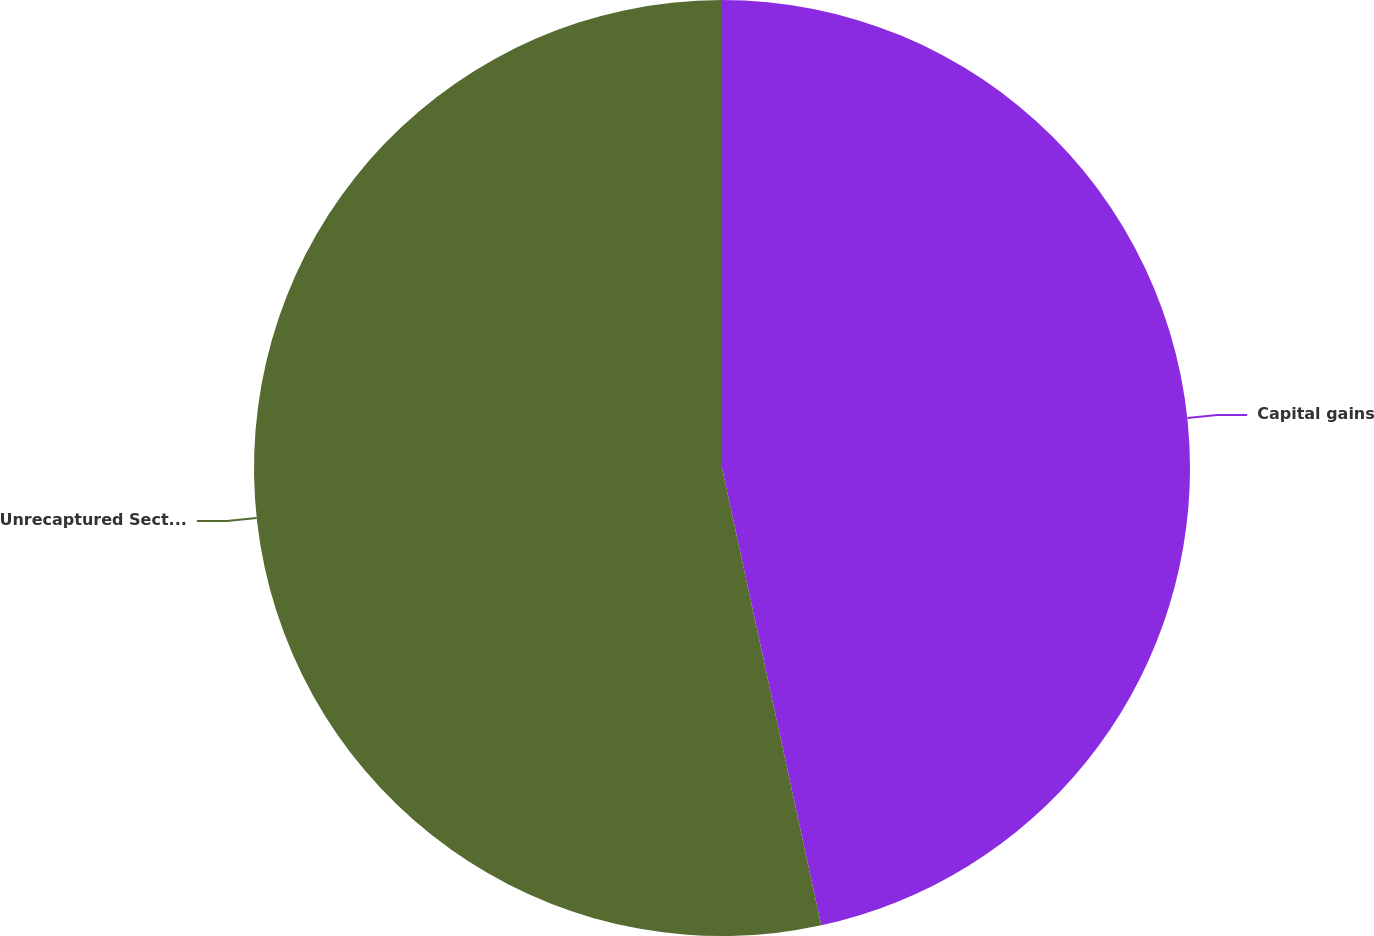<chart> <loc_0><loc_0><loc_500><loc_500><pie_chart><fcel>Capital gains<fcel>Unrecaptured Section 1250 gain<nl><fcel>46.6%<fcel>53.4%<nl></chart> 